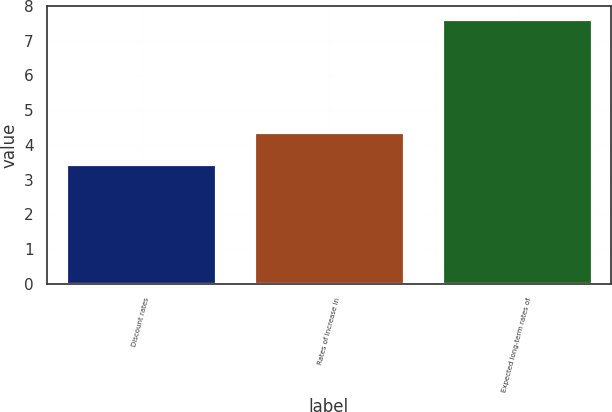Convert chart to OTSL. <chart><loc_0><loc_0><loc_500><loc_500><bar_chart><fcel>Discount rates<fcel>Rates of increase in<fcel>Expected long-term rates of<nl><fcel>3.45<fcel>4.36<fcel>7.62<nl></chart> 